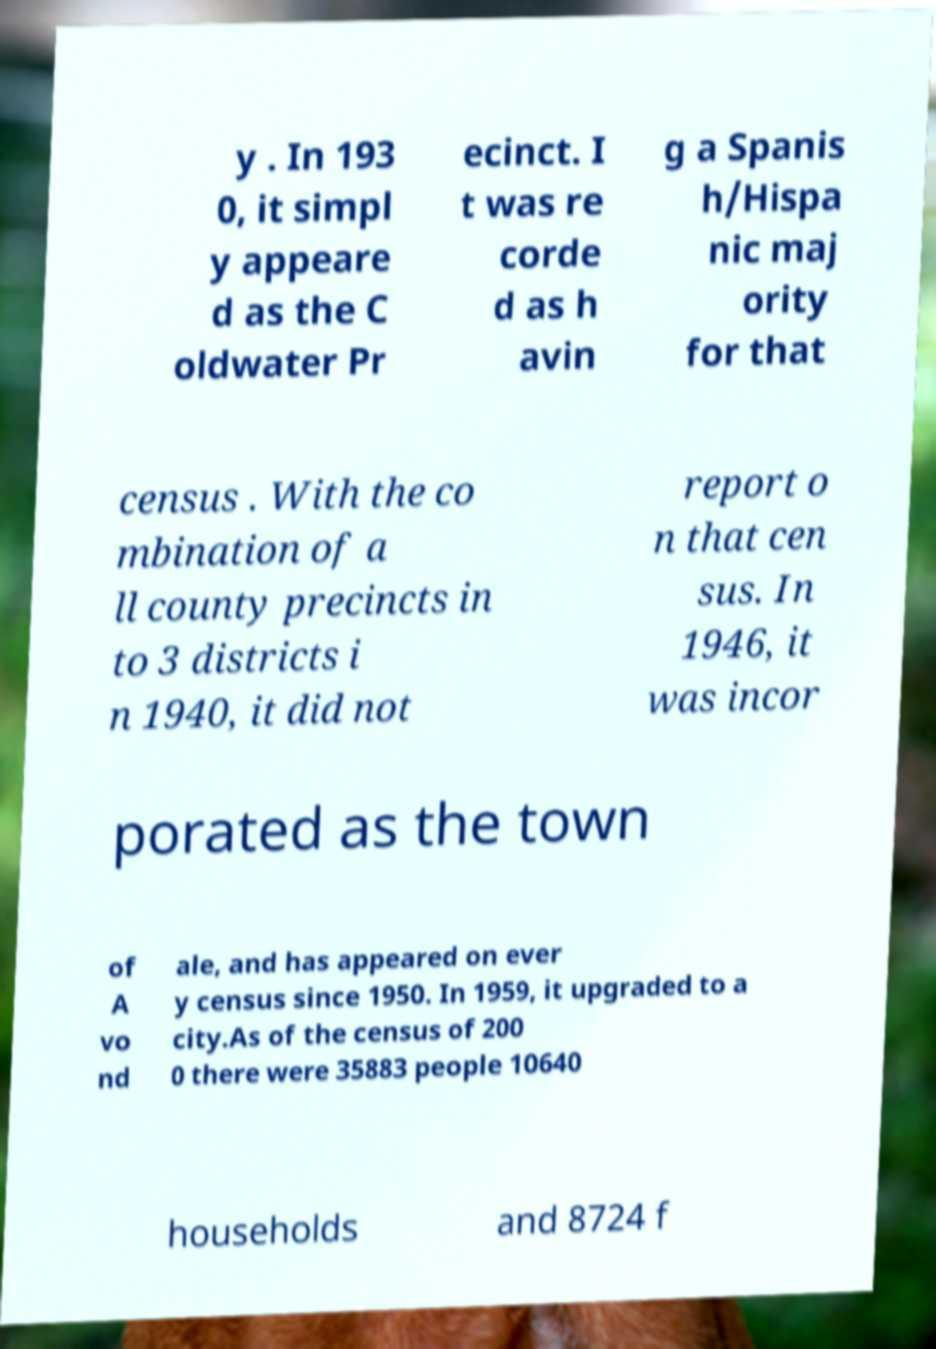Could you assist in decoding the text presented in this image and type it out clearly? y . In 193 0, it simpl y appeare d as the C oldwater Pr ecinct. I t was re corde d as h avin g a Spanis h/Hispa nic maj ority for that census . With the co mbination of a ll county precincts in to 3 districts i n 1940, it did not report o n that cen sus. In 1946, it was incor porated as the town of A vo nd ale, and has appeared on ever y census since 1950. In 1959, it upgraded to a city.As of the census of 200 0 there were 35883 people 10640 households and 8724 f 